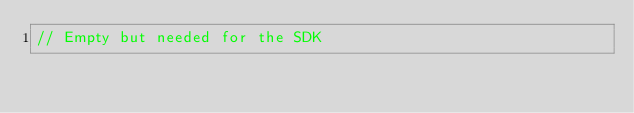<code> <loc_0><loc_0><loc_500><loc_500><_C_>// Empty but needed for the SDK
</code> 